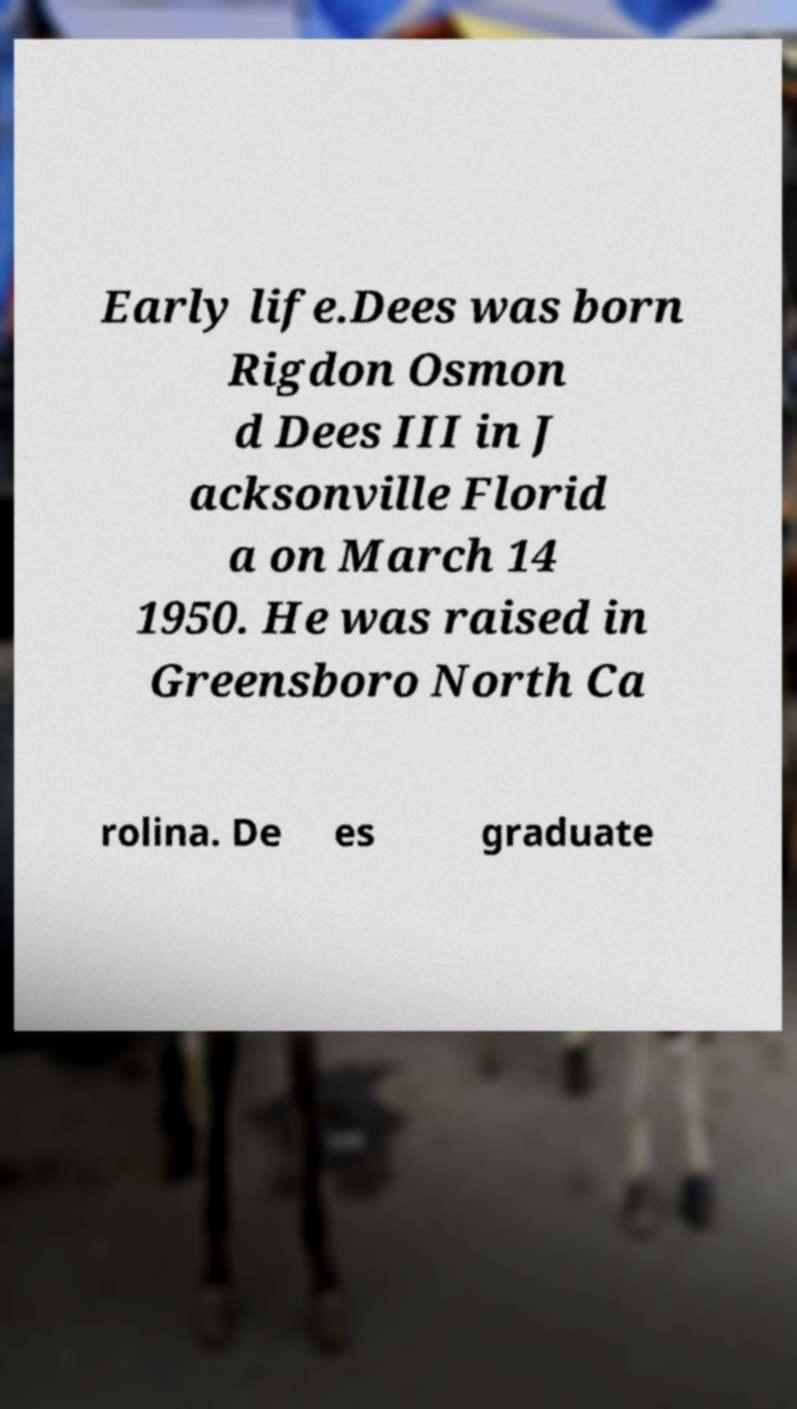Please identify and transcribe the text found in this image. Early life.Dees was born Rigdon Osmon d Dees III in J acksonville Florid a on March 14 1950. He was raised in Greensboro North Ca rolina. De es graduate 